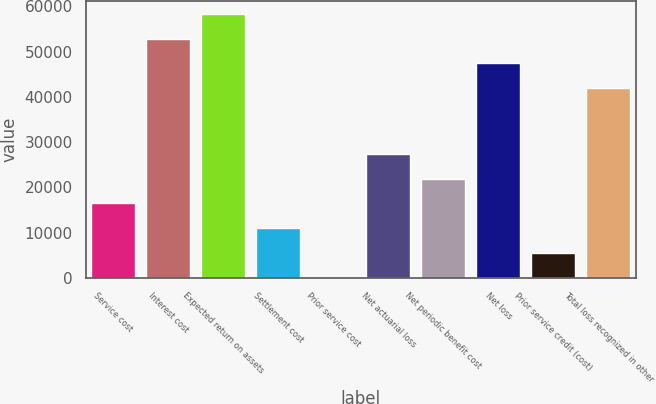<chart> <loc_0><loc_0><loc_500><loc_500><bar_chart><fcel>Service cost<fcel>Interest cost<fcel>Expected return on assets<fcel>Settlement cost<fcel>Prior service cost<fcel>Net actuarial loss<fcel>Net periodic benefit cost<fcel>Net loss<fcel>Prior service credit (cost)<fcel>Total loss recognized in other<nl><fcel>16474.8<fcel>52889.2<fcel>58377.8<fcel>10986.2<fcel>9<fcel>27452<fcel>21963.4<fcel>47400.6<fcel>5497.6<fcel>41912<nl></chart> 